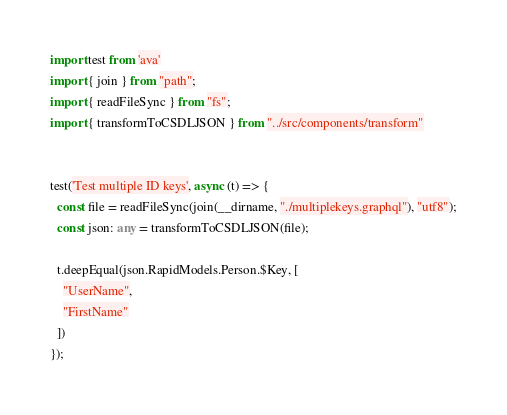<code> <loc_0><loc_0><loc_500><loc_500><_TypeScript_>import test from 'ava'
import { join } from "path";
import { readFileSync } from "fs";
import { transformToCSDLJSON } from "../src/components/transform"


test('Test multiple ID keys', async (t) => {
  const file = readFileSync(join(__dirname, "./multiplekeys.graphql"), "utf8");
  const json: any = transformToCSDLJSON(file);

  t.deepEqual(json.RapidModels.Person.$Key, [
    "UserName",
    "FirstName"
  ])
});



</code> 